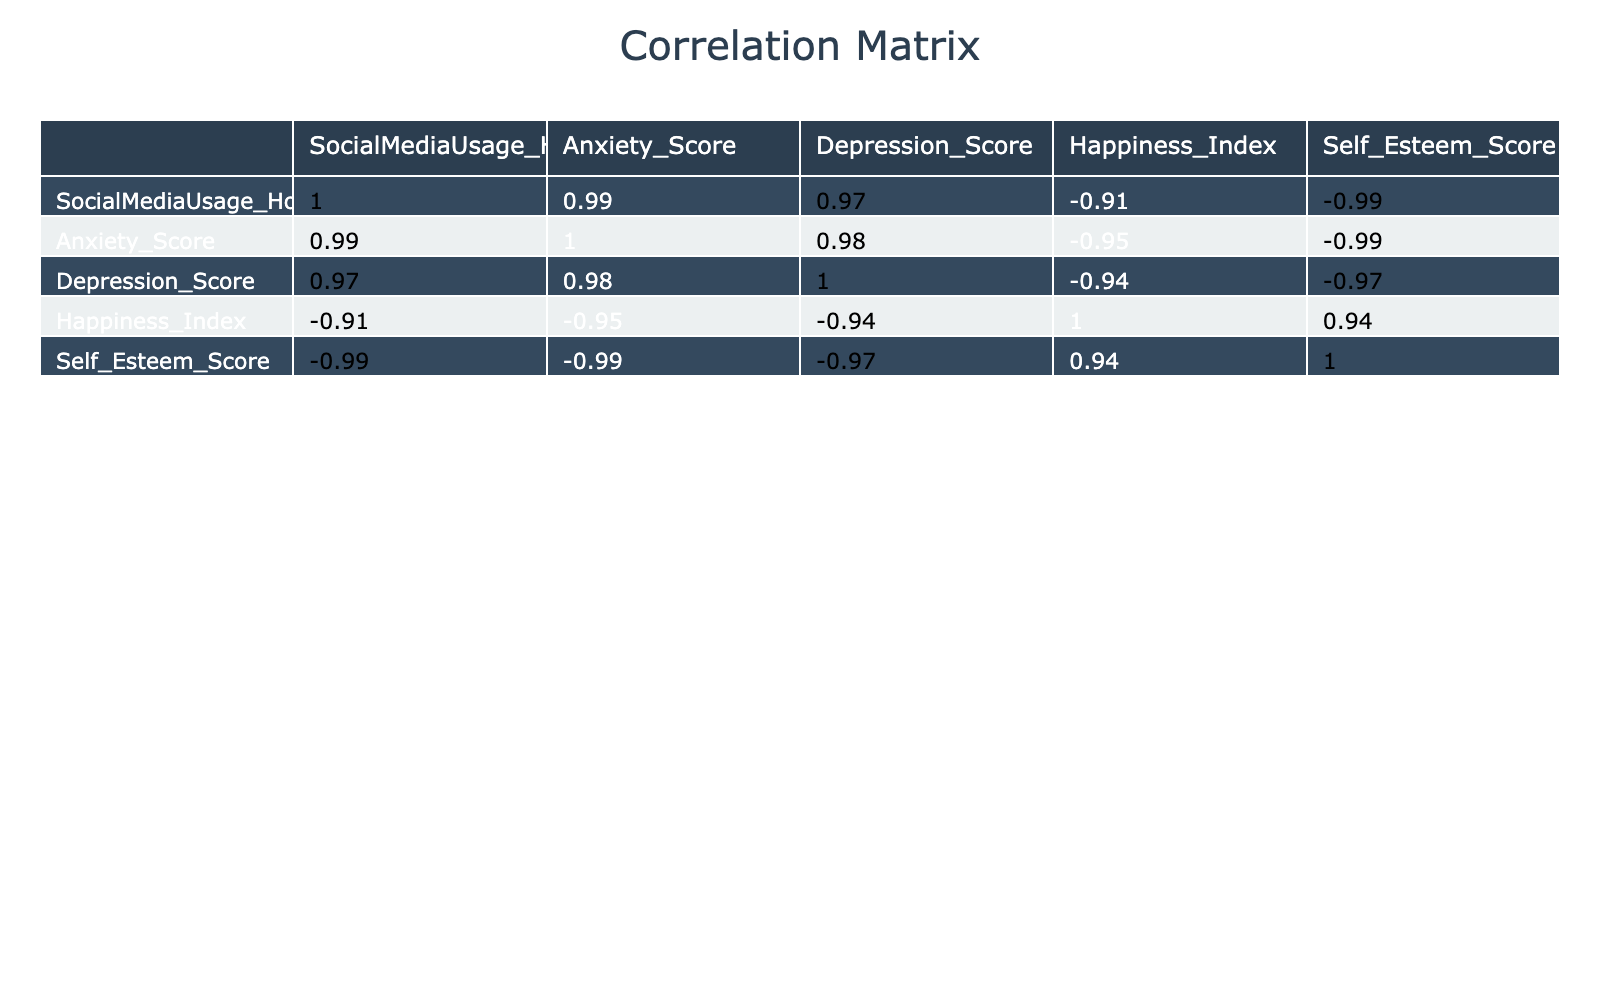What is the correlation between social media usage and anxiety scores? From the table, we can look at the correlation coefficient for SocialMediaUsage_Hours and Anxiety_Score, which is 0.88. This indicates a strong positive correlation.
Answer: 0.88 What is the lowest happiness index recorded? By examining the Happiness_Index column, the lowest value is 2, which corresponds to the highest social media usage and anxiety!
Answer: 2 Is there a positive correlation between self-esteem and the happiness index? The correlation coefficient between Self_Esteem_Score and Happiness_Index is 0.53, indicating a moderate positive correlation.
Answer: Yes What is the method to find the average anxiety score from the data? To calculate the average anxiety score, sum all anxiety scores (7 + 5 + 8 + 4 + 9 + 3 + 6 + 5 + 8 + 4) = 57. There are 10 data points, so the average is 57/10 = 5.7.
Answer: 5.7 Which social media usage hour has the highest depression score? Looking at the table, we can see that the maximum depression score of 8 occurs at 5.0 hours of social media usage.
Answer: 5.0 hours What correlation exists between social media usage hours and self-esteem scores? The correlation coefficient between SocialMediaUsage_Hours and Self_Esteem_Score is -0.78, indicating a strong negative correlation. This suggests that higher social media usage is associated with lower self-esteem.
Answer: -0.78 What is the total sum of depression scores across all entries? To find the total sum of depression scores, we calculate 6 + 5 + 7 + 4 + 8 + 2 + 5 + 4 + 7 + 3 = 57.
Answer: 57 Is the average self-esteem score greater than 6? The average self-esteem score is calculated by summing all self-esteem scores (6 + 7 + 5 + 8 + 4 + 9 + 6 + 7 + 5 + 8) = 65. With 10 data points, the average is 65/10 = 6.5, which is greater than 6.
Answer: Yes What is the change in happiness index from the highest to the lowest anxiety score? The highest anxiety score is 9 (at 5.0 hours), with a happiness index of 2. The lowest anxiety score is 3 (at 0.5 hours), with a happiness index of 7. The change is 7 - 2 = 5.
Answer: 5 